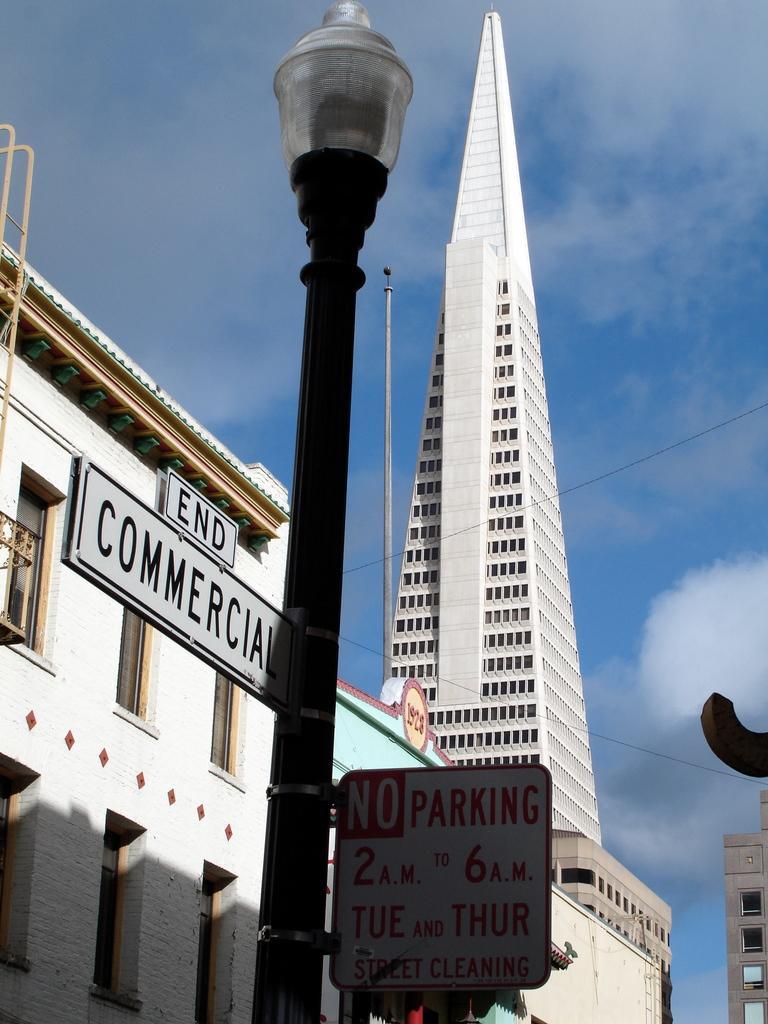Describe this image in one or two sentences. In this picture we can see some buildings, sine boards and street lamps to the pole. 